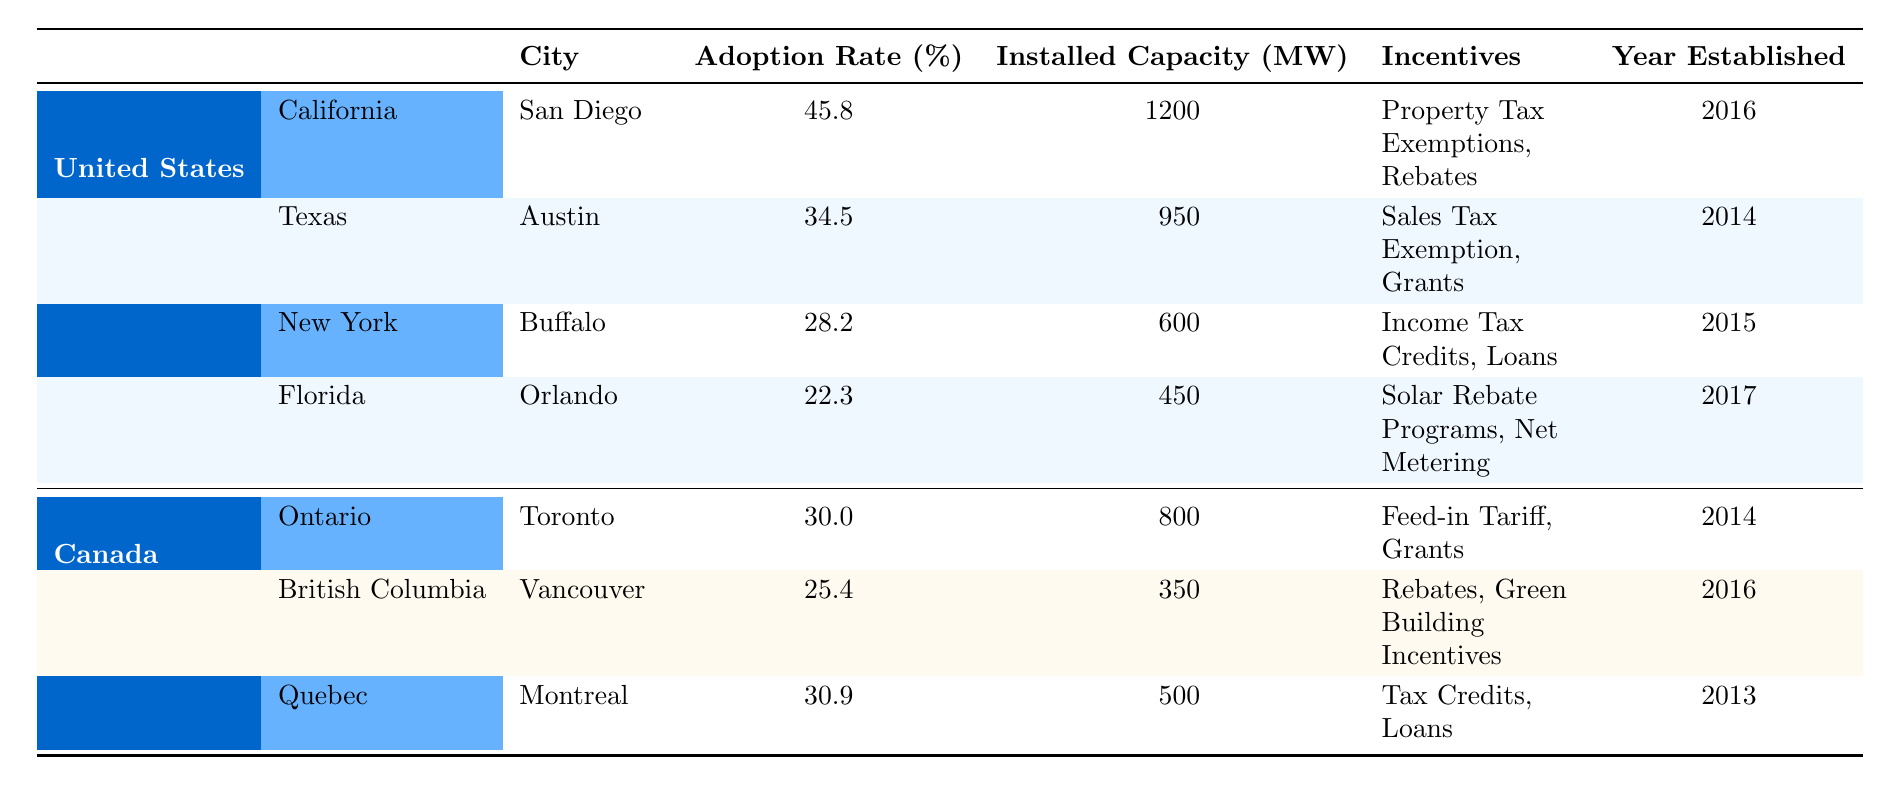What is the adoption rate of San Diego? The table shows the adoption rate for San Diego under California in the United States, which is listed as 45.8%.
Answer: 45.8% Which city has the highest adoption rate? Comparing the adoption rates from the table, San Diego (45.8%) is higher than Austin (34.5%), Buffalo (28.2%), Orlando (22.3%), Toronto (30.0%), Vancouver (25.4%), and Montreal (30.9%). Thus, San Diego has the highest adoption rate.
Answer: San Diego What is the total installed capacity of all cities in the United States listed? To find the total installed capacity for U.S. cities, add the installed capacities: 1200 (San Diego) + 950 (Austin) + 600 (Buffalo) + 450 (Orlando) = 3200 MW.
Answer: 3200 MW Is the adoption rate in Toronto higher than that in Orlando? Toronto's adoption rate is 30.0% and Orlando's adoption rate is 22.3%. Therefore, yes, the adoption rate in Toronto is higher than in Orlando.
Answer: Yes What is the average adoption rate of all cities in Canada from the table? The adoption rates for Canadian cities are: Toronto (30.0%), Vancouver (25.4%), and Montreal (30.9%). To calculate the average, sum these rates: 30.0 + 25.4 + 30.9 = 86.3. There are 3 cities, so divide 86.3 by 3, resulting in an average rate of approximately 28.77%.
Answer: 28.77% Which city has the largest installed capacity and what is it? By reviewing the installed capacities listed, San Diego has the largest capacity of 1200 MW.
Answer: San Diego, 1200 MW Did any city established after 2016 have an adoption rate above 30%? The only city established after 2016 is Orlando (2017) with an adoption rate of 22.3%, which is less than 30%. Therefore, no, there is no such city.
Answer: No What is the difference in adoption rates between Austin and Montreal? Austin's adoption rate is 34.5%, while Montreal's is 30.9%. The difference is calculated by subtracting Montreal's rate from Austin's: 34.5% - 30.9% = 3.6%.
Answer: 3.6% 